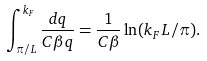Convert formula to latex. <formula><loc_0><loc_0><loc_500><loc_500>\int _ { \pi / L } ^ { k _ { F } } \frac { d q } { C \beta q } = \frac { 1 } { C \beta } \ln ( k _ { F } L / \pi ) .</formula> 